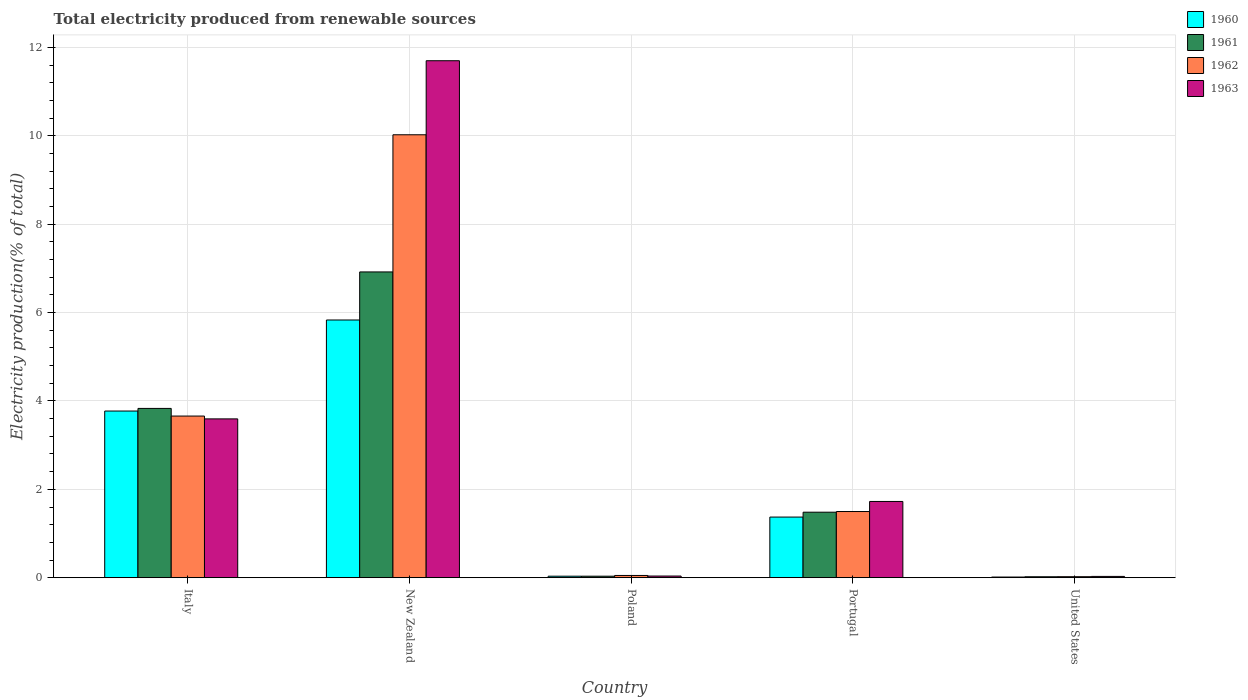How many different coloured bars are there?
Keep it short and to the point. 4. How many groups of bars are there?
Provide a short and direct response. 5. Are the number of bars per tick equal to the number of legend labels?
Provide a short and direct response. Yes. How many bars are there on the 5th tick from the left?
Your response must be concise. 4. What is the label of the 2nd group of bars from the left?
Make the answer very short. New Zealand. What is the total electricity produced in 1962 in Italy?
Your answer should be very brief. 3.66. Across all countries, what is the maximum total electricity produced in 1963?
Offer a very short reply. 11.7. Across all countries, what is the minimum total electricity produced in 1962?
Your answer should be very brief. 0.02. In which country was the total electricity produced in 1963 maximum?
Offer a very short reply. New Zealand. What is the total total electricity produced in 1963 in the graph?
Your response must be concise. 17.09. What is the difference between the total electricity produced in 1961 in Portugal and that in United States?
Your answer should be very brief. 1.46. What is the difference between the total electricity produced in 1961 in New Zealand and the total electricity produced in 1963 in Italy?
Your answer should be very brief. 3.33. What is the average total electricity produced in 1962 per country?
Provide a succinct answer. 3.05. What is the difference between the total electricity produced of/in 1961 and total electricity produced of/in 1960 in Portugal?
Your answer should be very brief. 0.11. In how many countries, is the total electricity produced in 1960 greater than 7.2 %?
Your answer should be very brief. 0. What is the ratio of the total electricity produced in 1960 in Italy to that in New Zealand?
Make the answer very short. 0.65. Is the total electricity produced in 1963 in Italy less than that in New Zealand?
Your response must be concise. Yes. What is the difference between the highest and the second highest total electricity produced in 1960?
Your response must be concise. -2.4. What is the difference between the highest and the lowest total electricity produced in 1962?
Your response must be concise. 10. Is it the case that in every country, the sum of the total electricity produced in 1962 and total electricity produced in 1960 is greater than the sum of total electricity produced in 1961 and total electricity produced in 1963?
Offer a very short reply. No. Is it the case that in every country, the sum of the total electricity produced in 1961 and total electricity produced in 1962 is greater than the total electricity produced in 1960?
Your response must be concise. Yes. What is the difference between two consecutive major ticks on the Y-axis?
Offer a very short reply. 2. Where does the legend appear in the graph?
Offer a terse response. Top right. How many legend labels are there?
Make the answer very short. 4. What is the title of the graph?
Offer a very short reply. Total electricity produced from renewable sources. What is the label or title of the X-axis?
Offer a terse response. Country. What is the Electricity production(% of total) in 1960 in Italy?
Offer a very short reply. 3.77. What is the Electricity production(% of total) of 1961 in Italy?
Give a very brief answer. 3.83. What is the Electricity production(% of total) in 1962 in Italy?
Ensure brevity in your answer.  3.66. What is the Electricity production(% of total) of 1963 in Italy?
Offer a terse response. 3.59. What is the Electricity production(% of total) of 1960 in New Zealand?
Offer a very short reply. 5.83. What is the Electricity production(% of total) of 1961 in New Zealand?
Your answer should be compact. 6.92. What is the Electricity production(% of total) of 1962 in New Zealand?
Offer a terse response. 10.02. What is the Electricity production(% of total) of 1963 in New Zealand?
Your answer should be compact. 11.7. What is the Electricity production(% of total) in 1960 in Poland?
Your answer should be compact. 0.03. What is the Electricity production(% of total) of 1961 in Poland?
Your response must be concise. 0.03. What is the Electricity production(% of total) in 1962 in Poland?
Offer a very short reply. 0.05. What is the Electricity production(% of total) in 1963 in Poland?
Provide a succinct answer. 0.04. What is the Electricity production(% of total) in 1960 in Portugal?
Your answer should be compact. 1.37. What is the Electricity production(% of total) of 1961 in Portugal?
Provide a short and direct response. 1.48. What is the Electricity production(% of total) of 1962 in Portugal?
Your answer should be very brief. 1.5. What is the Electricity production(% of total) of 1963 in Portugal?
Keep it short and to the point. 1.73. What is the Electricity production(% of total) of 1960 in United States?
Provide a succinct answer. 0.02. What is the Electricity production(% of total) of 1961 in United States?
Give a very brief answer. 0.02. What is the Electricity production(% of total) of 1962 in United States?
Your answer should be very brief. 0.02. What is the Electricity production(% of total) of 1963 in United States?
Provide a short and direct response. 0.03. Across all countries, what is the maximum Electricity production(% of total) in 1960?
Keep it short and to the point. 5.83. Across all countries, what is the maximum Electricity production(% of total) in 1961?
Your answer should be very brief. 6.92. Across all countries, what is the maximum Electricity production(% of total) of 1962?
Make the answer very short. 10.02. Across all countries, what is the maximum Electricity production(% of total) of 1963?
Provide a short and direct response. 11.7. Across all countries, what is the minimum Electricity production(% of total) in 1960?
Your answer should be very brief. 0.02. Across all countries, what is the minimum Electricity production(% of total) in 1961?
Your answer should be very brief. 0.02. Across all countries, what is the minimum Electricity production(% of total) in 1962?
Offer a terse response. 0.02. Across all countries, what is the minimum Electricity production(% of total) of 1963?
Your answer should be very brief. 0.03. What is the total Electricity production(% of total) in 1960 in the graph?
Provide a short and direct response. 11.03. What is the total Electricity production(% of total) in 1961 in the graph?
Give a very brief answer. 12.29. What is the total Electricity production(% of total) of 1962 in the graph?
Ensure brevity in your answer.  15.25. What is the total Electricity production(% of total) of 1963 in the graph?
Offer a terse response. 17.09. What is the difference between the Electricity production(% of total) of 1960 in Italy and that in New Zealand?
Provide a succinct answer. -2.06. What is the difference between the Electricity production(% of total) of 1961 in Italy and that in New Zealand?
Offer a terse response. -3.09. What is the difference between the Electricity production(% of total) of 1962 in Italy and that in New Zealand?
Your answer should be very brief. -6.37. What is the difference between the Electricity production(% of total) of 1963 in Italy and that in New Zealand?
Keep it short and to the point. -8.11. What is the difference between the Electricity production(% of total) in 1960 in Italy and that in Poland?
Your response must be concise. 3.74. What is the difference between the Electricity production(% of total) of 1961 in Italy and that in Poland?
Your response must be concise. 3.8. What is the difference between the Electricity production(% of total) of 1962 in Italy and that in Poland?
Ensure brevity in your answer.  3.61. What is the difference between the Electricity production(% of total) of 1963 in Italy and that in Poland?
Give a very brief answer. 3.56. What is the difference between the Electricity production(% of total) in 1960 in Italy and that in Portugal?
Keep it short and to the point. 2.4. What is the difference between the Electricity production(% of total) of 1961 in Italy and that in Portugal?
Your answer should be compact. 2.35. What is the difference between the Electricity production(% of total) of 1962 in Italy and that in Portugal?
Your answer should be very brief. 2.16. What is the difference between the Electricity production(% of total) of 1963 in Italy and that in Portugal?
Your response must be concise. 1.87. What is the difference between the Electricity production(% of total) of 1960 in Italy and that in United States?
Offer a terse response. 3.76. What is the difference between the Electricity production(% of total) in 1961 in Italy and that in United States?
Your answer should be compact. 3.81. What is the difference between the Electricity production(% of total) of 1962 in Italy and that in United States?
Give a very brief answer. 3.64. What is the difference between the Electricity production(% of total) of 1963 in Italy and that in United States?
Provide a succinct answer. 3.56. What is the difference between the Electricity production(% of total) in 1960 in New Zealand and that in Poland?
Make the answer very short. 5.8. What is the difference between the Electricity production(% of total) in 1961 in New Zealand and that in Poland?
Your answer should be very brief. 6.89. What is the difference between the Electricity production(% of total) in 1962 in New Zealand and that in Poland?
Offer a very short reply. 9.97. What is the difference between the Electricity production(% of total) in 1963 in New Zealand and that in Poland?
Give a very brief answer. 11.66. What is the difference between the Electricity production(% of total) of 1960 in New Zealand and that in Portugal?
Keep it short and to the point. 4.46. What is the difference between the Electricity production(% of total) in 1961 in New Zealand and that in Portugal?
Make the answer very short. 5.44. What is the difference between the Electricity production(% of total) in 1962 in New Zealand and that in Portugal?
Your answer should be very brief. 8.53. What is the difference between the Electricity production(% of total) of 1963 in New Zealand and that in Portugal?
Provide a succinct answer. 9.97. What is the difference between the Electricity production(% of total) in 1960 in New Zealand and that in United States?
Your response must be concise. 5.82. What is the difference between the Electricity production(% of total) in 1961 in New Zealand and that in United States?
Make the answer very short. 6.9. What is the difference between the Electricity production(% of total) of 1962 in New Zealand and that in United States?
Ensure brevity in your answer.  10. What is the difference between the Electricity production(% of total) in 1963 in New Zealand and that in United States?
Provide a short and direct response. 11.67. What is the difference between the Electricity production(% of total) of 1960 in Poland and that in Portugal?
Offer a very short reply. -1.34. What is the difference between the Electricity production(% of total) in 1961 in Poland and that in Portugal?
Keep it short and to the point. -1.45. What is the difference between the Electricity production(% of total) of 1962 in Poland and that in Portugal?
Provide a succinct answer. -1.45. What is the difference between the Electricity production(% of total) of 1963 in Poland and that in Portugal?
Offer a terse response. -1.69. What is the difference between the Electricity production(% of total) of 1960 in Poland and that in United States?
Keep it short and to the point. 0.02. What is the difference between the Electricity production(% of total) of 1961 in Poland and that in United States?
Your answer should be very brief. 0.01. What is the difference between the Electricity production(% of total) of 1962 in Poland and that in United States?
Your answer should be very brief. 0.03. What is the difference between the Electricity production(% of total) in 1963 in Poland and that in United States?
Provide a succinct answer. 0.01. What is the difference between the Electricity production(% of total) in 1960 in Portugal and that in United States?
Your answer should be compact. 1.36. What is the difference between the Electricity production(% of total) in 1961 in Portugal and that in United States?
Offer a very short reply. 1.46. What is the difference between the Electricity production(% of total) in 1962 in Portugal and that in United States?
Provide a short and direct response. 1.48. What is the difference between the Electricity production(% of total) of 1963 in Portugal and that in United States?
Your response must be concise. 1.7. What is the difference between the Electricity production(% of total) in 1960 in Italy and the Electricity production(% of total) in 1961 in New Zealand?
Offer a very short reply. -3.15. What is the difference between the Electricity production(% of total) in 1960 in Italy and the Electricity production(% of total) in 1962 in New Zealand?
Offer a terse response. -6.25. What is the difference between the Electricity production(% of total) in 1960 in Italy and the Electricity production(% of total) in 1963 in New Zealand?
Give a very brief answer. -7.93. What is the difference between the Electricity production(% of total) of 1961 in Italy and the Electricity production(% of total) of 1962 in New Zealand?
Ensure brevity in your answer.  -6.19. What is the difference between the Electricity production(% of total) of 1961 in Italy and the Electricity production(% of total) of 1963 in New Zealand?
Your response must be concise. -7.87. What is the difference between the Electricity production(% of total) of 1962 in Italy and the Electricity production(% of total) of 1963 in New Zealand?
Give a very brief answer. -8.04. What is the difference between the Electricity production(% of total) of 1960 in Italy and the Electricity production(% of total) of 1961 in Poland?
Provide a succinct answer. 3.74. What is the difference between the Electricity production(% of total) of 1960 in Italy and the Electricity production(% of total) of 1962 in Poland?
Keep it short and to the point. 3.72. What is the difference between the Electricity production(% of total) of 1960 in Italy and the Electricity production(% of total) of 1963 in Poland?
Provide a succinct answer. 3.73. What is the difference between the Electricity production(% of total) in 1961 in Italy and the Electricity production(% of total) in 1962 in Poland?
Keep it short and to the point. 3.78. What is the difference between the Electricity production(% of total) in 1961 in Italy and the Electricity production(% of total) in 1963 in Poland?
Keep it short and to the point. 3.79. What is the difference between the Electricity production(% of total) in 1962 in Italy and the Electricity production(% of total) in 1963 in Poland?
Your response must be concise. 3.62. What is the difference between the Electricity production(% of total) in 1960 in Italy and the Electricity production(% of total) in 1961 in Portugal?
Provide a succinct answer. 2.29. What is the difference between the Electricity production(% of total) in 1960 in Italy and the Electricity production(% of total) in 1962 in Portugal?
Ensure brevity in your answer.  2.27. What is the difference between the Electricity production(% of total) of 1960 in Italy and the Electricity production(% of total) of 1963 in Portugal?
Offer a very short reply. 2.05. What is the difference between the Electricity production(% of total) in 1961 in Italy and the Electricity production(% of total) in 1962 in Portugal?
Your answer should be very brief. 2.33. What is the difference between the Electricity production(% of total) in 1961 in Italy and the Electricity production(% of total) in 1963 in Portugal?
Make the answer very short. 2.11. What is the difference between the Electricity production(% of total) in 1962 in Italy and the Electricity production(% of total) in 1963 in Portugal?
Your answer should be very brief. 1.93. What is the difference between the Electricity production(% of total) in 1960 in Italy and the Electricity production(% of total) in 1961 in United States?
Provide a short and direct response. 3.75. What is the difference between the Electricity production(% of total) of 1960 in Italy and the Electricity production(% of total) of 1962 in United States?
Your answer should be compact. 3.75. What is the difference between the Electricity production(% of total) of 1960 in Italy and the Electricity production(% of total) of 1963 in United States?
Offer a very short reply. 3.74. What is the difference between the Electricity production(% of total) of 1961 in Italy and the Electricity production(% of total) of 1962 in United States?
Make the answer very short. 3.81. What is the difference between the Electricity production(% of total) in 1961 in Italy and the Electricity production(% of total) in 1963 in United States?
Your answer should be compact. 3.8. What is the difference between the Electricity production(% of total) of 1962 in Italy and the Electricity production(% of total) of 1963 in United States?
Your answer should be very brief. 3.63. What is the difference between the Electricity production(% of total) in 1960 in New Zealand and the Electricity production(% of total) in 1961 in Poland?
Ensure brevity in your answer.  5.8. What is the difference between the Electricity production(% of total) in 1960 in New Zealand and the Electricity production(% of total) in 1962 in Poland?
Your answer should be compact. 5.78. What is the difference between the Electricity production(% of total) of 1960 in New Zealand and the Electricity production(% of total) of 1963 in Poland?
Offer a terse response. 5.79. What is the difference between the Electricity production(% of total) in 1961 in New Zealand and the Electricity production(% of total) in 1962 in Poland?
Your answer should be very brief. 6.87. What is the difference between the Electricity production(% of total) in 1961 in New Zealand and the Electricity production(% of total) in 1963 in Poland?
Make the answer very short. 6.88. What is the difference between the Electricity production(% of total) in 1962 in New Zealand and the Electricity production(% of total) in 1963 in Poland?
Your response must be concise. 9.99. What is the difference between the Electricity production(% of total) of 1960 in New Zealand and the Electricity production(% of total) of 1961 in Portugal?
Offer a terse response. 4.35. What is the difference between the Electricity production(% of total) in 1960 in New Zealand and the Electricity production(% of total) in 1962 in Portugal?
Ensure brevity in your answer.  4.33. What is the difference between the Electricity production(% of total) in 1960 in New Zealand and the Electricity production(% of total) in 1963 in Portugal?
Provide a short and direct response. 4.11. What is the difference between the Electricity production(% of total) of 1961 in New Zealand and the Electricity production(% of total) of 1962 in Portugal?
Provide a short and direct response. 5.42. What is the difference between the Electricity production(% of total) of 1961 in New Zealand and the Electricity production(% of total) of 1963 in Portugal?
Give a very brief answer. 5.19. What is the difference between the Electricity production(% of total) in 1962 in New Zealand and the Electricity production(% of total) in 1963 in Portugal?
Your response must be concise. 8.3. What is the difference between the Electricity production(% of total) of 1960 in New Zealand and the Electricity production(% of total) of 1961 in United States?
Your answer should be compact. 5.81. What is the difference between the Electricity production(% of total) in 1960 in New Zealand and the Electricity production(% of total) in 1962 in United States?
Your answer should be compact. 5.81. What is the difference between the Electricity production(% of total) of 1960 in New Zealand and the Electricity production(% of total) of 1963 in United States?
Give a very brief answer. 5.8. What is the difference between the Electricity production(% of total) in 1961 in New Zealand and the Electricity production(% of total) in 1962 in United States?
Provide a succinct answer. 6.9. What is the difference between the Electricity production(% of total) in 1961 in New Zealand and the Electricity production(% of total) in 1963 in United States?
Offer a terse response. 6.89. What is the difference between the Electricity production(% of total) of 1962 in New Zealand and the Electricity production(% of total) of 1963 in United States?
Provide a short and direct response. 10. What is the difference between the Electricity production(% of total) of 1960 in Poland and the Electricity production(% of total) of 1961 in Portugal?
Make the answer very short. -1.45. What is the difference between the Electricity production(% of total) in 1960 in Poland and the Electricity production(% of total) in 1962 in Portugal?
Keep it short and to the point. -1.46. What is the difference between the Electricity production(% of total) of 1960 in Poland and the Electricity production(% of total) of 1963 in Portugal?
Provide a succinct answer. -1.69. What is the difference between the Electricity production(% of total) in 1961 in Poland and the Electricity production(% of total) in 1962 in Portugal?
Your response must be concise. -1.46. What is the difference between the Electricity production(% of total) of 1961 in Poland and the Electricity production(% of total) of 1963 in Portugal?
Provide a short and direct response. -1.69. What is the difference between the Electricity production(% of total) in 1962 in Poland and the Electricity production(% of total) in 1963 in Portugal?
Offer a very short reply. -1.67. What is the difference between the Electricity production(% of total) of 1960 in Poland and the Electricity production(% of total) of 1961 in United States?
Provide a short and direct response. 0.01. What is the difference between the Electricity production(% of total) of 1960 in Poland and the Electricity production(% of total) of 1962 in United States?
Ensure brevity in your answer.  0.01. What is the difference between the Electricity production(% of total) in 1960 in Poland and the Electricity production(% of total) in 1963 in United States?
Provide a short and direct response. 0. What is the difference between the Electricity production(% of total) in 1961 in Poland and the Electricity production(% of total) in 1962 in United States?
Offer a terse response. 0.01. What is the difference between the Electricity production(% of total) of 1961 in Poland and the Electricity production(% of total) of 1963 in United States?
Make the answer very short. 0. What is the difference between the Electricity production(% of total) in 1962 in Poland and the Electricity production(% of total) in 1963 in United States?
Your answer should be compact. 0.02. What is the difference between the Electricity production(% of total) in 1960 in Portugal and the Electricity production(% of total) in 1961 in United States?
Your answer should be very brief. 1.35. What is the difference between the Electricity production(% of total) of 1960 in Portugal and the Electricity production(% of total) of 1962 in United States?
Make the answer very short. 1.35. What is the difference between the Electricity production(% of total) in 1960 in Portugal and the Electricity production(% of total) in 1963 in United States?
Make the answer very short. 1.34. What is the difference between the Electricity production(% of total) of 1961 in Portugal and the Electricity production(% of total) of 1962 in United States?
Offer a very short reply. 1.46. What is the difference between the Electricity production(% of total) in 1961 in Portugal and the Electricity production(% of total) in 1963 in United States?
Keep it short and to the point. 1.45. What is the difference between the Electricity production(% of total) of 1962 in Portugal and the Electricity production(% of total) of 1963 in United States?
Give a very brief answer. 1.47. What is the average Electricity production(% of total) of 1960 per country?
Keep it short and to the point. 2.21. What is the average Electricity production(% of total) in 1961 per country?
Make the answer very short. 2.46. What is the average Electricity production(% of total) in 1962 per country?
Keep it short and to the point. 3.05. What is the average Electricity production(% of total) in 1963 per country?
Provide a short and direct response. 3.42. What is the difference between the Electricity production(% of total) of 1960 and Electricity production(% of total) of 1961 in Italy?
Ensure brevity in your answer.  -0.06. What is the difference between the Electricity production(% of total) of 1960 and Electricity production(% of total) of 1962 in Italy?
Ensure brevity in your answer.  0.11. What is the difference between the Electricity production(% of total) of 1960 and Electricity production(% of total) of 1963 in Italy?
Offer a very short reply. 0.18. What is the difference between the Electricity production(% of total) in 1961 and Electricity production(% of total) in 1962 in Italy?
Offer a terse response. 0.17. What is the difference between the Electricity production(% of total) in 1961 and Electricity production(% of total) in 1963 in Italy?
Your answer should be compact. 0.24. What is the difference between the Electricity production(% of total) of 1962 and Electricity production(% of total) of 1963 in Italy?
Provide a short and direct response. 0.06. What is the difference between the Electricity production(% of total) in 1960 and Electricity production(% of total) in 1961 in New Zealand?
Your response must be concise. -1.09. What is the difference between the Electricity production(% of total) in 1960 and Electricity production(% of total) in 1962 in New Zealand?
Keep it short and to the point. -4.19. What is the difference between the Electricity production(% of total) in 1960 and Electricity production(% of total) in 1963 in New Zealand?
Offer a terse response. -5.87. What is the difference between the Electricity production(% of total) in 1961 and Electricity production(% of total) in 1962 in New Zealand?
Offer a very short reply. -3.1. What is the difference between the Electricity production(% of total) in 1961 and Electricity production(% of total) in 1963 in New Zealand?
Offer a terse response. -4.78. What is the difference between the Electricity production(% of total) in 1962 and Electricity production(% of total) in 1963 in New Zealand?
Provide a short and direct response. -1.68. What is the difference between the Electricity production(% of total) of 1960 and Electricity production(% of total) of 1962 in Poland?
Your answer should be very brief. -0.02. What is the difference between the Electricity production(% of total) in 1960 and Electricity production(% of total) in 1963 in Poland?
Your answer should be very brief. -0. What is the difference between the Electricity production(% of total) of 1961 and Electricity production(% of total) of 1962 in Poland?
Provide a short and direct response. -0.02. What is the difference between the Electricity production(% of total) of 1961 and Electricity production(% of total) of 1963 in Poland?
Your answer should be very brief. -0. What is the difference between the Electricity production(% of total) of 1962 and Electricity production(% of total) of 1963 in Poland?
Make the answer very short. 0.01. What is the difference between the Electricity production(% of total) in 1960 and Electricity production(% of total) in 1961 in Portugal?
Provide a succinct answer. -0.11. What is the difference between the Electricity production(% of total) in 1960 and Electricity production(% of total) in 1962 in Portugal?
Offer a terse response. -0.13. What is the difference between the Electricity production(% of total) of 1960 and Electricity production(% of total) of 1963 in Portugal?
Your answer should be very brief. -0.35. What is the difference between the Electricity production(% of total) in 1961 and Electricity production(% of total) in 1962 in Portugal?
Your answer should be very brief. -0.02. What is the difference between the Electricity production(% of total) of 1961 and Electricity production(% of total) of 1963 in Portugal?
Offer a very short reply. -0.24. What is the difference between the Electricity production(% of total) in 1962 and Electricity production(% of total) in 1963 in Portugal?
Provide a succinct answer. -0.23. What is the difference between the Electricity production(% of total) in 1960 and Electricity production(% of total) in 1961 in United States?
Make the answer very short. -0.01. What is the difference between the Electricity production(% of total) of 1960 and Electricity production(% of total) of 1962 in United States?
Make the answer very short. -0.01. What is the difference between the Electricity production(% of total) of 1960 and Electricity production(% of total) of 1963 in United States?
Give a very brief answer. -0.01. What is the difference between the Electricity production(% of total) of 1961 and Electricity production(% of total) of 1962 in United States?
Provide a short and direct response. -0. What is the difference between the Electricity production(% of total) of 1961 and Electricity production(% of total) of 1963 in United States?
Ensure brevity in your answer.  -0.01. What is the difference between the Electricity production(% of total) of 1962 and Electricity production(% of total) of 1963 in United States?
Give a very brief answer. -0.01. What is the ratio of the Electricity production(% of total) in 1960 in Italy to that in New Zealand?
Provide a short and direct response. 0.65. What is the ratio of the Electricity production(% of total) in 1961 in Italy to that in New Zealand?
Your response must be concise. 0.55. What is the ratio of the Electricity production(% of total) in 1962 in Italy to that in New Zealand?
Give a very brief answer. 0.36. What is the ratio of the Electricity production(% of total) of 1963 in Italy to that in New Zealand?
Provide a short and direct response. 0.31. What is the ratio of the Electricity production(% of total) in 1960 in Italy to that in Poland?
Provide a succinct answer. 110.45. What is the ratio of the Electricity production(% of total) in 1961 in Italy to that in Poland?
Offer a very short reply. 112.3. What is the ratio of the Electricity production(% of total) in 1962 in Italy to that in Poland?
Provide a short and direct response. 71.88. What is the ratio of the Electricity production(% of total) of 1963 in Italy to that in Poland?
Provide a succinct answer. 94.84. What is the ratio of the Electricity production(% of total) in 1960 in Italy to that in Portugal?
Offer a terse response. 2.75. What is the ratio of the Electricity production(% of total) in 1961 in Italy to that in Portugal?
Give a very brief answer. 2.58. What is the ratio of the Electricity production(% of total) in 1962 in Italy to that in Portugal?
Provide a short and direct response. 2.44. What is the ratio of the Electricity production(% of total) of 1963 in Italy to that in Portugal?
Offer a terse response. 2.08. What is the ratio of the Electricity production(% of total) of 1960 in Italy to that in United States?
Your answer should be very brief. 247.25. What is the ratio of the Electricity production(% of total) of 1961 in Italy to that in United States?
Offer a very short reply. 177.87. What is the ratio of the Electricity production(% of total) of 1962 in Italy to that in United States?
Offer a very short reply. 160.56. What is the ratio of the Electricity production(% of total) in 1963 in Italy to that in United States?
Provide a succinct answer. 122.12. What is the ratio of the Electricity production(% of total) in 1960 in New Zealand to that in Poland?
Provide a short and direct response. 170.79. What is the ratio of the Electricity production(% of total) in 1961 in New Zealand to that in Poland?
Offer a very short reply. 202.83. What is the ratio of the Electricity production(% of total) of 1962 in New Zealand to that in Poland?
Keep it short and to the point. 196.95. What is the ratio of the Electricity production(% of total) of 1963 in New Zealand to that in Poland?
Your answer should be very brief. 308.73. What is the ratio of the Electricity production(% of total) of 1960 in New Zealand to that in Portugal?
Ensure brevity in your answer.  4.25. What is the ratio of the Electricity production(% of total) in 1961 in New Zealand to that in Portugal?
Give a very brief answer. 4.67. What is the ratio of the Electricity production(% of total) of 1962 in New Zealand to that in Portugal?
Offer a terse response. 6.69. What is the ratio of the Electricity production(% of total) of 1963 in New Zealand to that in Portugal?
Offer a very short reply. 6.78. What is the ratio of the Electricity production(% of total) of 1960 in New Zealand to that in United States?
Make the answer very short. 382.31. What is the ratio of the Electricity production(% of total) of 1961 in New Zealand to that in United States?
Make the answer very short. 321.25. What is the ratio of the Electricity production(% of total) in 1962 in New Zealand to that in United States?
Offer a terse response. 439.93. What is the ratio of the Electricity production(% of total) of 1963 in New Zealand to that in United States?
Provide a short and direct response. 397.5. What is the ratio of the Electricity production(% of total) in 1960 in Poland to that in Portugal?
Keep it short and to the point. 0.02. What is the ratio of the Electricity production(% of total) of 1961 in Poland to that in Portugal?
Provide a short and direct response. 0.02. What is the ratio of the Electricity production(% of total) of 1962 in Poland to that in Portugal?
Your response must be concise. 0.03. What is the ratio of the Electricity production(% of total) in 1963 in Poland to that in Portugal?
Ensure brevity in your answer.  0.02. What is the ratio of the Electricity production(% of total) of 1960 in Poland to that in United States?
Offer a very short reply. 2.24. What is the ratio of the Electricity production(% of total) of 1961 in Poland to that in United States?
Provide a succinct answer. 1.58. What is the ratio of the Electricity production(% of total) of 1962 in Poland to that in United States?
Offer a very short reply. 2.23. What is the ratio of the Electricity production(% of total) of 1963 in Poland to that in United States?
Your answer should be very brief. 1.29. What is the ratio of the Electricity production(% of total) in 1960 in Portugal to that in United States?
Your response must be concise. 89.96. What is the ratio of the Electricity production(% of total) in 1961 in Portugal to that in United States?
Offer a very short reply. 68.83. What is the ratio of the Electricity production(% of total) in 1962 in Portugal to that in United States?
Your response must be concise. 65.74. What is the ratio of the Electricity production(% of total) of 1963 in Portugal to that in United States?
Provide a short and direct response. 58.63. What is the difference between the highest and the second highest Electricity production(% of total) in 1960?
Provide a short and direct response. 2.06. What is the difference between the highest and the second highest Electricity production(% of total) in 1961?
Give a very brief answer. 3.09. What is the difference between the highest and the second highest Electricity production(% of total) of 1962?
Ensure brevity in your answer.  6.37. What is the difference between the highest and the second highest Electricity production(% of total) of 1963?
Provide a short and direct response. 8.11. What is the difference between the highest and the lowest Electricity production(% of total) in 1960?
Offer a terse response. 5.82. What is the difference between the highest and the lowest Electricity production(% of total) in 1961?
Provide a succinct answer. 6.9. What is the difference between the highest and the lowest Electricity production(% of total) of 1962?
Keep it short and to the point. 10. What is the difference between the highest and the lowest Electricity production(% of total) in 1963?
Your response must be concise. 11.67. 